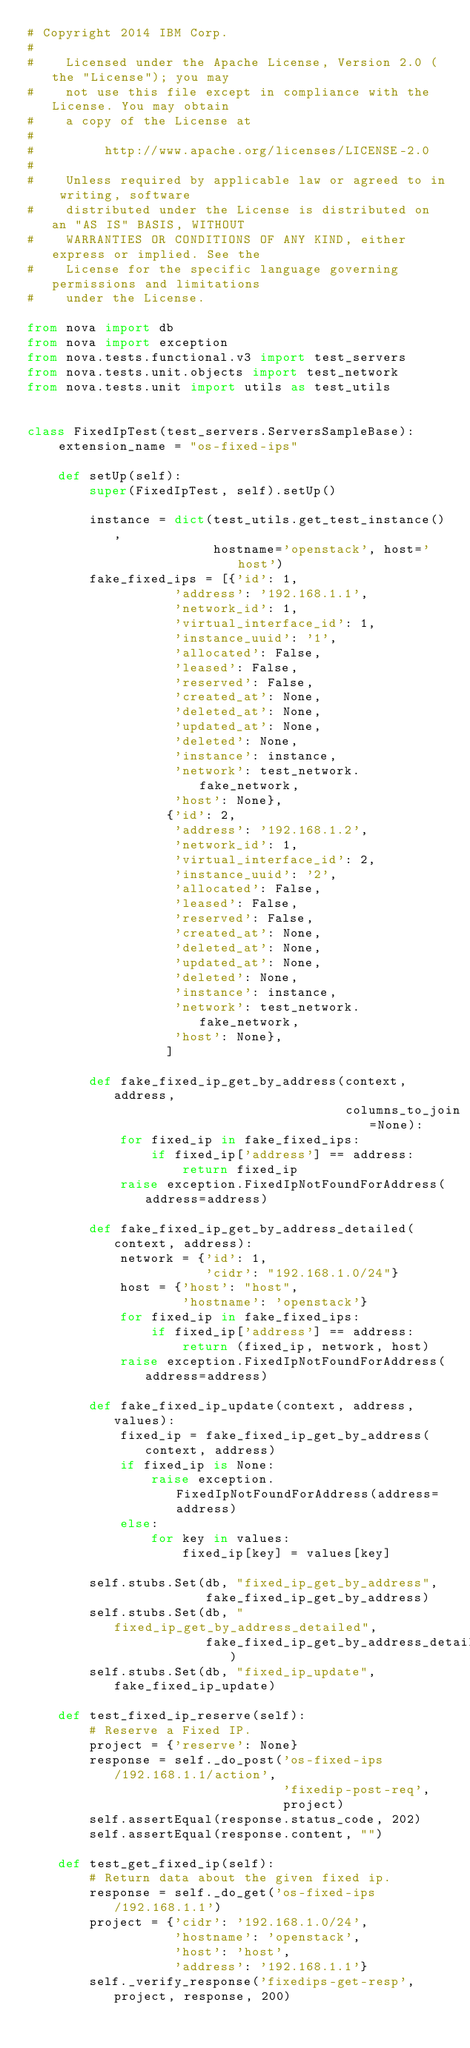Convert code to text. <code><loc_0><loc_0><loc_500><loc_500><_Python_># Copyright 2014 IBM Corp.
#
#    Licensed under the Apache License, Version 2.0 (the "License"); you may
#    not use this file except in compliance with the License. You may obtain
#    a copy of the License at
#
#         http://www.apache.org/licenses/LICENSE-2.0
#
#    Unless required by applicable law or agreed to in writing, software
#    distributed under the License is distributed on an "AS IS" BASIS, WITHOUT
#    WARRANTIES OR CONDITIONS OF ANY KIND, either express or implied. See the
#    License for the specific language governing permissions and limitations
#    under the License.

from nova import db
from nova import exception
from nova.tests.functional.v3 import test_servers
from nova.tests.unit.objects import test_network
from nova.tests.unit import utils as test_utils


class FixedIpTest(test_servers.ServersSampleBase):
    extension_name = "os-fixed-ips"

    def setUp(self):
        super(FixedIpTest, self).setUp()

        instance = dict(test_utils.get_test_instance(),
                        hostname='openstack', host='host')
        fake_fixed_ips = [{'id': 1,
                   'address': '192.168.1.1',
                   'network_id': 1,
                   'virtual_interface_id': 1,
                   'instance_uuid': '1',
                   'allocated': False,
                   'leased': False,
                   'reserved': False,
                   'created_at': None,
                   'deleted_at': None,
                   'updated_at': None,
                   'deleted': None,
                   'instance': instance,
                   'network': test_network.fake_network,
                   'host': None},
                  {'id': 2,
                   'address': '192.168.1.2',
                   'network_id': 1,
                   'virtual_interface_id': 2,
                   'instance_uuid': '2',
                   'allocated': False,
                   'leased': False,
                   'reserved': False,
                   'created_at': None,
                   'deleted_at': None,
                   'updated_at': None,
                   'deleted': None,
                   'instance': instance,
                   'network': test_network.fake_network,
                   'host': None},
                  ]

        def fake_fixed_ip_get_by_address(context, address,
                                         columns_to_join=None):
            for fixed_ip in fake_fixed_ips:
                if fixed_ip['address'] == address:
                    return fixed_ip
            raise exception.FixedIpNotFoundForAddress(address=address)

        def fake_fixed_ip_get_by_address_detailed(context, address):
            network = {'id': 1,
                       'cidr': "192.168.1.0/24"}
            host = {'host': "host",
                    'hostname': 'openstack'}
            for fixed_ip in fake_fixed_ips:
                if fixed_ip['address'] == address:
                    return (fixed_ip, network, host)
            raise exception.FixedIpNotFoundForAddress(address=address)

        def fake_fixed_ip_update(context, address, values):
            fixed_ip = fake_fixed_ip_get_by_address(context, address)
            if fixed_ip is None:
                raise exception.FixedIpNotFoundForAddress(address=address)
            else:
                for key in values:
                    fixed_ip[key] = values[key]

        self.stubs.Set(db, "fixed_ip_get_by_address",
                       fake_fixed_ip_get_by_address)
        self.stubs.Set(db, "fixed_ip_get_by_address_detailed",
                       fake_fixed_ip_get_by_address_detailed)
        self.stubs.Set(db, "fixed_ip_update", fake_fixed_ip_update)

    def test_fixed_ip_reserve(self):
        # Reserve a Fixed IP.
        project = {'reserve': None}
        response = self._do_post('os-fixed-ips/192.168.1.1/action',
                                 'fixedip-post-req',
                                 project)
        self.assertEqual(response.status_code, 202)
        self.assertEqual(response.content, "")

    def test_get_fixed_ip(self):
        # Return data about the given fixed ip.
        response = self._do_get('os-fixed-ips/192.168.1.1')
        project = {'cidr': '192.168.1.0/24',
                   'hostname': 'openstack',
                   'host': 'host',
                   'address': '192.168.1.1'}
        self._verify_response('fixedips-get-resp', project, response, 200)
</code> 